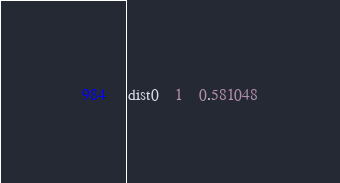<code> <loc_0><loc_0><loc_500><loc_500><_SQL_>dist0	1	0.581048</code> 